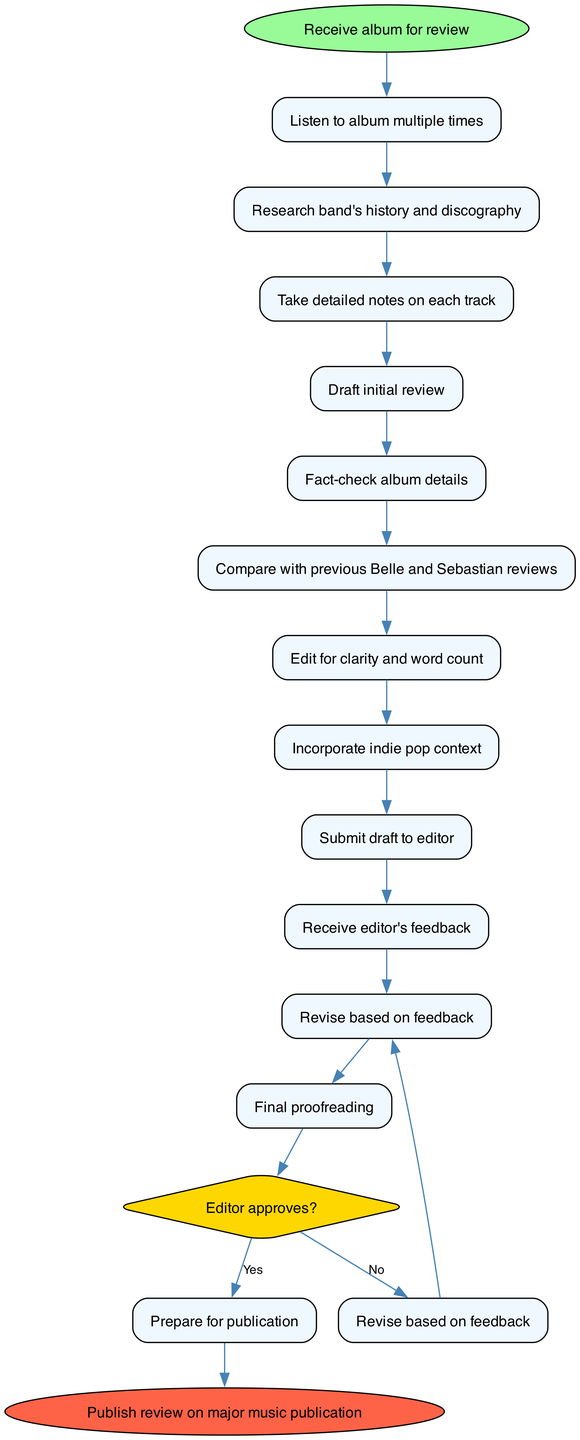What is the first activity in the diagram? The first activity is "Listen to album multiple times." This can be verified by looking at the list of activities starting from the first node connected to the start node.
Answer: Listen to album multiple times How many activities are there in total? Counting the activities listed, there are 12 activities in the diagram, from "Listen to album multiple times" to "Final proofreading."
Answer: 12 What is the last activity before the decision node? The last activity before the decision node is "Final proofreading." It is connected to the decision node as the last activity performed before reaching the decision.
Answer: Final proofreading What happens if the editor approves the review? If the editor approves, the next step is "Prepare for publication." This is the outcome from the decision node indicating successful approval.
Answer: Prepare for publication How many nodes are shaped like diamonds in the diagram? There is one diamond-shaped node, which represents the decision point about whether the editor approves the review.
Answer: 1 Which activity involves comparing with previous reviews? The activity that involves comparing with previous reviews is "Compare with previous Belle and Sebastian reviews." It is one of the steps listed in the activities.
Answer: Compare with previous Belle and Sebastian reviews What is the last node in the process? The last node in the process is "Publish review on major music publication." This is the endpoint of the activity diagram following the decision and approval flow.
Answer: Publish review on major music publication What should be done after receiving editor's feedback if the review is not approved? If the review is not approved, the next step is "Revise based on feedback." This outlines the course of action to take when edits are required.
Answer: Revise based on feedback Which two activities occur after drafting the initial review? The two activities that occur after "Draft initial review" are "Fact-check album details" and "Compare with previous Belle and Sebastian reviews." Both follow directly after the drafting activity.
Answer: Fact-check album details, Compare with previous Belle and Sebastian reviews 